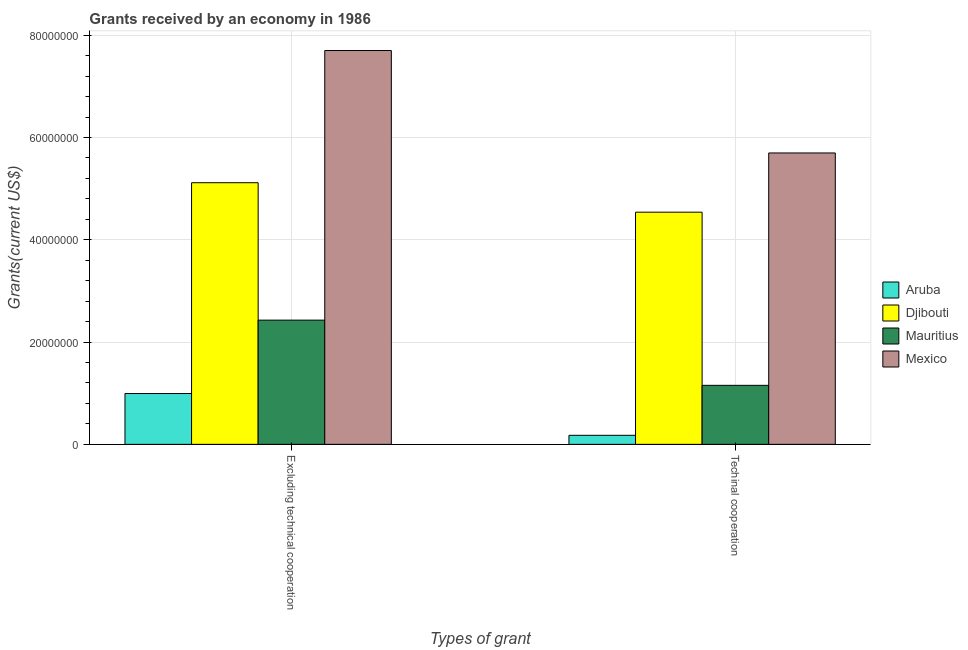Are the number of bars per tick equal to the number of legend labels?
Give a very brief answer. Yes. Are the number of bars on each tick of the X-axis equal?
Your answer should be very brief. Yes. How many bars are there on the 2nd tick from the right?
Provide a succinct answer. 4. What is the label of the 2nd group of bars from the left?
Offer a very short reply. Techinal cooperation. What is the amount of grants received(excluding technical cooperation) in Mexico?
Offer a terse response. 7.70e+07. Across all countries, what is the maximum amount of grants received(excluding technical cooperation)?
Ensure brevity in your answer.  7.70e+07. Across all countries, what is the minimum amount of grants received(including technical cooperation)?
Your answer should be compact. 1.77e+06. In which country was the amount of grants received(including technical cooperation) minimum?
Your answer should be compact. Aruba. What is the total amount of grants received(excluding technical cooperation) in the graph?
Your response must be concise. 1.62e+08. What is the difference between the amount of grants received(excluding technical cooperation) in Aruba and that in Mexico?
Offer a terse response. -6.71e+07. What is the difference between the amount of grants received(including technical cooperation) in Djibouti and the amount of grants received(excluding technical cooperation) in Mauritius?
Ensure brevity in your answer.  2.11e+07. What is the average amount of grants received(excluding technical cooperation) per country?
Offer a very short reply. 4.06e+07. What is the difference between the amount of grants received(including technical cooperation) and amount of grants received(excluding technical cooperation) in Mauritius?
Make the answer very short. -1.28e+07. What is the ratio of the amount of grants received(including technical cooperation) in Aruba to that in Mauritius?
Offer a very short reply. 0.15. In how many countries, is the amount of grants received(including technical cooperation) greater than the average amount of grants received(including technical cooperation) taken over all countries?
Offer a terse response. 2. What does the 1st bar from the left in Excluding technical cooperation represents?
Your answer should be very brief. Aruba. Are all the bars in the graph horizontal?
Ensure brevity in your answer.  No. How many countries are there in the graph?
Make the answer very short. 4. What is the title of the graph?
Offer a very short reply. Grants received by an economy in 1986. Does "Cuba" appear as one of the legend labels in the graph?
Make the answer very short. No. What is the label or title of the X-axis?
Provide a short and direct response. Types of grant. What is the label or title of the Y-axis?
Ensure brevity in your answer.  Grants(current US$). What is the Grants(current US$) of Aruba in Excluding technical cooperation?
Make the answer very short. 9.94e+06. What is the Grants(current US$) of Djibouti in Excluding technical cooperation?
Your response must be concise. 5.12e+07. What is the Grants(current US$) in Mauritius in Excluding technical cooperation?
Your response must be concise. 2.43e+07. What is the Grants(current US$) of Mexico in Excluding technical cooperation?
Make the answer very short. 7.70e+07. What is the Grants(current US$) of Aruba in Techinal cooperation?
Offer a very short reply. 1.77e+06. What is the Grants(current US$) in Djibouti in Techinal cooperation?
Give a very brief answer. 4.54e+07. What is the Grants(current US$) of Mauritius in Techinal cooperation?
Keep it short and to the point. 1.15e+07. What is the Grants(current US$) of Mexico in Techinal cooperation?
Ensure brevity in your answer.  5.70e+07. Across all Types of grant, what is the maximum Grants(current US$) in Aruba?
Provide a short and direct response. 9.94e+06. Across all Types of grant, what is the maximum Grants(current US$) in Djibouti?
Your answer should be very brief. 5.12e+07. Across all Types of grant, what is the maximum Grants(current US$) in Mauritius?
Give a very brief answer. 2.43e+07. Across all Types of grant, what is the maximum Grants(current US$) in Mexico?
Your response must be concise. 7.70e+07. Across all Types of grant, what is the minimum Grants(current US$) in Aruba?
Provide a short and direct response. 1.77e+06. Across all Types of grant, what is the minimum Grants(current US$) in Djibouti?
Keep it short and to the point. 4.54e+07. Across all Types of grant, what is the minimum Grants(current US$) of Mauritius?
Make the answer very short. 1.15e+07. Across all Types of grant, what is the minimum Grants(current US$) in Mexico?
Provide a succinct answer. 5.70e+07. What is the total Grants(current US$) in Aruba in the graph?
Make the answer very short. 1.17e+07. What is the total Grants(current US$) of Djibouti in the graph?
Ensure brevity in your answer.  9.66e+07. What is the total Grants(current US$) of Mauritius in the graph?
Your answer should be compact. 3.58e+07. What is the total Grants(current US$) in Mexico in the graph?
Offer a very short reply. 1.34e+08. What is the difference between the Grants(current US$) of Aruba in Excluding technical cooperation and that in Techinal cooperation?
Provide a short and direct response. 8.17e+06. What is the difference between the Grants(current US$) in Djibouti in Excluding technical cooperation and that in Techinal cooperation?
Give a very brief answer. 5.76e+06. What is the difference between the Grants(current US$) of Mauritius in Excluding technical cooperation and that in Techinal cooperation?
Ensure brevity in your answer.  1.28e+07. What is the difference between the Grants(current US$) of Mexico in Excluding technical cooperation and that in Techinal cooperation?
Your answer should be very brief. 2.00e+07. What is the difference between the Grants(current US$) in Aruba in Excluding technical cooperation and the Grants(current US$) in Djibouti in Techinal cooperation?
Offer a terse response. -3.55e+07. What is the difference between the Grants(current US$) of Aruba in Excluding technical cooperation and the Grants(current US$) of Mauritius in Techinal cooperation?
Your answer should be compact. -1.60e+06. What is the difference between the Grants(current US$) in Aruba in Excluding technical cooperation and the Grants(current US$) in Mexico in Techinal cooperation?
Provide a succinct answer. -4.70e+07. What is the difference between the Grants(current US$) in Djibouti in Excluding technical cooperation and the Grants(current US$) in Mauritius in Techinal cooperation?
Make the answer very short. 3.96e+07. What is the difference between the Grants(current US$) of Djibouti in Excluding technical cooperation and the Grants(current US$) of Mexico in Techinal cooperation?
Your response must be concise. -5.82e+06. What is the difference between the Grants(current US$) of Mauritius in Excluding technical cooperation and the Grants(current US$) of Mexico in Techinal cooperation?
Offer a very short reply. -3.27e+07. What is the average Grants(current US$) of Aruba per Types of grant?
Your response must be concise. 5.86e+06. What is the average Grants(current US$) in Djibouti per Types of grant?
Offer a very short reply. 4.83e+07. What is the average Grants(current US$) of Mauritius per Types of grant?
Provide a short and direct response. 1.79e+07. What is the average Grants(current US$) in Mexico per Types of grant?
Ensure brevity in your answer.  6.70e+07. What is the difference between the Grants(current US$) in Aruba and Grants(current US$) in Djibouti in Excluding technical cooperation?
Make the answer very short. -4.12e+07. What is the difference between the Grants(current US$) of Aruba and Grants(current US$) of Mauritius in Excluding technical cooperation?
Keep it short and to the point. -1.44e+07. What is the difference between the Grants(current US$) in Aruba and Grants(current US$) in Mexico in Excluding technical cooperation?
Ensure brevity in your answer.  -6.71e+07. What is the difference between the Grants(current US$) in Djibouti and Grants(current US$) in Mauritius in Excluding technical cooperation?
Provide a succinct answer. 2.69e+07. What is the difference between the Grants(current US$) in Djibouti and Grants(current US$) in Mexico in Excluding technical cooperation?
Your response must be concise. -2.58e+07. What is the difference between the Grants(current US$) in Mauritius and Grants(current US$) in Mexico in Excluding technical cooperation?
Provide a succinct answer. -5.27e+07. What is the difference between the Grants(current US$) in Aruba and Grants(current US$) in Djibouti in Techinal cooperation?
Your answer should be very brief. -4.36e+07. What is the difference between the Grants(current US$) of Aruba and Grants(current US$) of Mauritius in Techinal cooperation?
Keep it short and to the point. -9.77e+06. What is the difference between the Grants(current US$) of Aruba and Grants(current US$) of Mexico in Techinal cooperation?
Your answer should be very brief. -5.52e+07. What is the difference between the Grants(current US$) of Djibouti and Grants(current US$) of Mauritius in Techinal cooperation?
Provide a succinct answer. 3.39e+07. What is the difference between the Grants(current US$) in Djibouti and Grants(current US$) in Mexico in Techinal cooperation?
Ensure brevity in your answer.  -1.16e+07. What is the difference between the Grants(current US$) in Mauritius and Grants(current US$) in Mexico in Techinal cooperation?
Your answer should be very brief. -4.54e+07. What is the ratio of the Grants(current US$) of Aruba in Excluding technical cooperation to that in Techinal cooperation?
Your answer should be compact. 5.62. What is the ratio of the Grants(current US$) of Djibouti in Excluding technical cooperation to that in Techinal cooperation?
Provide a succinct answer. 1.13. What is the ratio of the Grants(current US$) of Mauritius in Excluding technical cooperation to that in Techinal cooperation?
Offer a terse response. 2.1. What is the ratio of the Grants(current US$) of Mexico in Excluding technical cooperation to that in Techinal cooperation?
Ensure brevity in your answer.  1.35. What is the difference between the highest and the second highest Grants(current US$) in Aruba?
Ensure brevity in your answer.  8.17e+06. What is the difference between the highest and the second highest Grants(current US$) of Djibouti?
Offer a terse response. 5.76e+06. What is the difference between the highest and the second highest Grants(current US$) of Mauritius?
Ensure brevity in your answer.  1.28e+07. What is the difference between the highest and the second highest Grants(current US$) in Mexico?
Your answer should be very brief. 2.00e+07. What is the difference between the highest and the lowest Grants(current US$) in Aruba?
Offer a terse response. 8.17e+06. What is the difference between the highest and the lowest Grants(current US$) of Djibouti?
Your answer should be very brief. 5.76e+06. What is the difference between the highest and the lowest Grants(current US$) of Mauritius?
Ensure brevity in your answer.  1.28e+07. What is the difference between the highest and the lowest Grants(current US$) in Mexico?
Ensure brevity in your answer.  2.00e+07. 